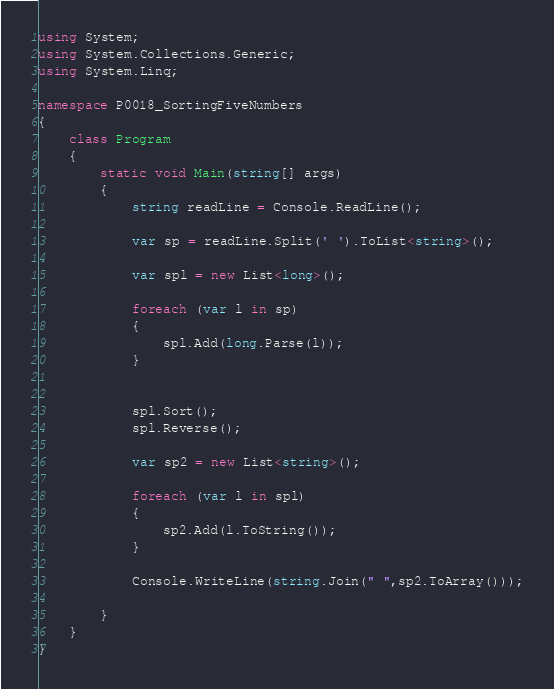<code> <loc_0><loc_0><loc_500><loc_500><_C#_>using System;
using System.Collections.Generic;
using System.Linq;

namespace P0018_SortingFiveNumbers
{
    class Program
    {
        static void Main(string[] args)
        {
            string readLine = Console.ReadLine(); 
                        
            var sp = readLine.Split(' ').ToList<string>();

            var spl = new List<long>();

            foreach (var l in sp) 
            {
                spl.Add(long.Parse(l));
            }


            spl.Sort();
            spl.Reverse();

            var sp2 = new List<string>();

            foreach (var l in spl)
            {
                sp2.Add(l.ToString());
            }

            Console.WriteLine(string.Join(" ",sp2.ToArray()));

        }
    }
}</code> 